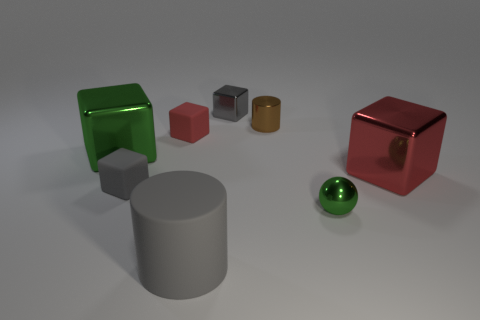Subtract all gray metallic blocks. How many blocks are left? 4 Subtract all green cubes. How many cubes are left? 4 Subtract 2 cubes. How many cubes are left? 3 Subtract all yellow cubes. Subtract all gray cylinders. How many cubes are left? 5 Add 2 shiny spheres. How many objects exist? 10 Subtract all cylinders. How many objects are left? 6 Subtract all small green shiny cubes. Subtract all tiny shiny objects. How many objects are left? 5 Add 2 big green blocks. How many big green blocks are left? 3 Add 6 rubber things. How many rubber things exist? 9 Subtract 1 gray cylinders. How many objects are left? 7 